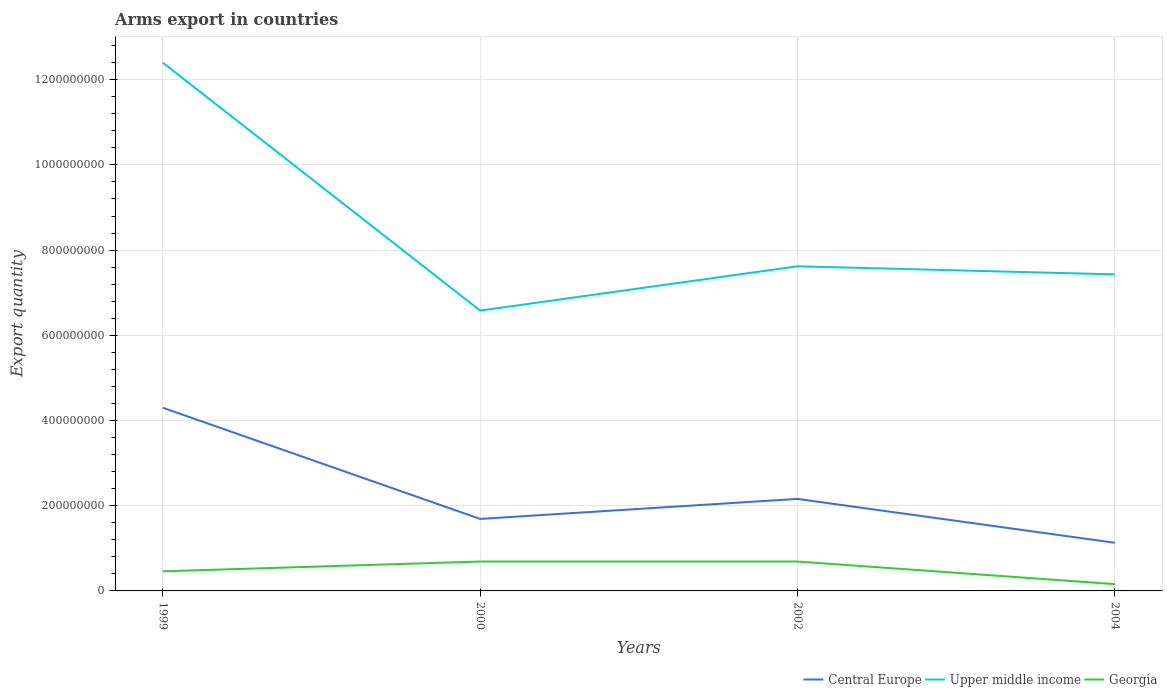How many different coloured lines are there?
Make the answer very short. 3. Does the line corresponding to Central Europe intersect with the line corresponding to Upper middle income?
Your response must be concise. No. Is the number of lines equal to the number of legend labels?
Provide a short and direct response. Yes. Across all years, what is the maximum total arms export in Central Europe?
Offer a very short reply. 1.13e+08. In which year was the total arms export in Central Europe maximum?
Provide a short and direct response. 2004. What is the total total arms export in Central Europe in the graph?
Your answer should be very brief. 3.17e+08. What is the difference between the highest and the second highest total arms export in Central Europe?
Keep it short and to the point. 3.17e+08. What is the difference between the highest and the lowest total arms export in Georgia?
Give a very brief answer. 2. How many lines are there?
Provide a short and direct response. 3. How many years are there in the graph?
Provide a succinct answer. 4. Are the values on the major ticks of Y-axis written in scientific E-notation?
Your response must be concise. No. Where does the legend appear in the graph?
Your answer should be very brief. Bottom right. How are the legend labels stacked?
Offer a very short reply. Horizontal. What is the title of the graph?
Your response must be concise. Arms export in countries. Does "Lithuania" appear as one of the legend labels in the graph?
Give a very brief answer. No. What is the label or title of the Y-axis?
Your answer should be very brief. Export quantity. What is the Export quantity in Central Europe in 1999?
Keep it short and to the point. 4.30e+08. What is the Export quantity in Upper middle income in 1999?
Provide a short and direct response. 1.24e+09. What is the Export quantity of Georgia in 1999?
Keep it short and to the point. 4.60e+07. What is the Export quantity of Central Europe in 2000?
Keep it short and to the point. 1.69e+08. What is the Export quantity of Upper middle income in 2000?
Your answer should be very brief. 6.58e+08. What is the Export quantity in Georgia in 2000?
Your answer should be compact. 6.90e+07. What is the Export quantity of Central Europe in 2002?
Your answer should be very brief. 2.16e+08. What is the Export quantity of Upper middle income in 2002?
Ensure brevity in your answer.  7.62e+08. What is the Export quantity in Georgia in 2002?
Your answer should be very brief. 6.90e+07. What is the Export quantity in Central Europe in 2004?
Provide a succinct answer. 1.13e+08. What is the Export quantity of Upper middle income in 2004?
Ensure brevity in your answer.  7.43e+08. What is the Export quantity in Georgia in 2004?
Your response must be concise. 1.60e+07. Across all years, what is the maximum Export quantity of Central Europe?
Make the answer very short. 4.30e+08. Across all years, what is the maximum Export quantity of Upper middle income?
Make the answer very short. 1.24e+09. Across all years, what is the maximum Export quantity in Georgia?
Keep it short and to the point. 6.90e+07. Across all years, what is the minimum Export quantity in Central Europe?
Ensure brevity in your answer.  1.13e+08. Across all years, what is the minimum Export quantity of Upper middle income?
Offer a terse response. 6.58e+08. Across all years, what is the minimum Export quantity of Georgia?
Provide a short and direct response. 1.60e+07. What is the total Export quantity in Central Europe in the graph?
Your response must be concise. 9.28e+08. What is the total Export quantity of Upper middle income in the graph?
Your answer should be very brief. 3.40e+09. What is the total Export quantity in Georgia in the graph?
Give a very brief answer. 2.00e+08. What is the difference between the Export quantity in Central Europe in 1999 and that in 2000?
Your response must be concise. 2.61e+08. What is the difference between the Export quantity in Upper middle income in 1999 and that in 2000?
Your answer should be very brief. 5.82e+08. What is the difference between the Export quantity of Georgia in 1999 and that in 2000?
Provide a succinct answer. -2.30e+07. What is the difference between the Export quantity in Central Europe in 1999 and that in 2002?
Your answer should be very brief. 2.14e+08. What is the difference between the Export quantity of Upper middle income in 1999 and that in 2002?
Provide a succinct answer. 4.78e+08. What is the difference between the Export quantity of Georgia in 1999 and that in 2002?
Keep it short and to the point. -2.30e+07. What is the difference between the Export quantity of Central Europe in 1999 and that in 2004?
Your response must be concise. 3.17e+08. What is the difference between the Export quantity of Upper middle income in 1999 and that in 2004?
Provide a succinct answer. 4.97e+08. What is the difference between the Export quantity in Georgia in 1999 and that in 2004?
Provide a succinct answer. 3.00e+07. What is the difference between the Export quantity of Central Europe in 2000 and that in 2002?
Your response must be concise. -4.70e+07. What is the difference between the Export quantity in Upper middle income in 2000 and that in 2002?
Your answer should be compact. -1.04e+08. What is the difference between the Export quantity of Central Europe in 2000 and that in 2004?
Your answer should be compact. 5.60e+07. What is the difference between the Export quantity of Upper middle income in 2000 and that in 2004?
Provide a short and direct response. -8.50e+07. What is the difference between the Export quantity in Georgia in 2000 and that in 2004?
Your answer should be compact. 5.30e+07. What is the difference between the Export quantity of Central Europe in 2002 and that in 2004?
Provide a succinct answer. 1.03e+08. What is the difference between the Export quantity of Upper middle income in 2002 and that in 2004?
Offer a terse response. 1.90e+07. What is the difference between the Export quantity in Georgia in 2002 and that in 2004?
Provide a short and direct response. 5.30e+07. What is the difference between the Export quantity in Central Europe in 1999 and the Export quantity in Upper middle income in 2000?
Provide a short and direct response. -2.28e+08. What is the difference between the Export quantity of Central Europe in 1999 and the Export quantity of Georgia in 2000?
Give a very brief answer. 3.61e+08. What is the difference between the Export quantity in Upper middle income in 1999 and the Export quantity in Georgia in 2000?
Your answer should be very brief. 1.17e+09. What is the difference between the Export quantity in Central Europe in 1999 and the Export quantity in Upper middle income in 2002?
Keep it short and to the point. -3.32e+08. What is the difference between the Export quantity in Central Europe in 1999 and the Export quantity in Georgia in 2002?
Keep it short and to the point. 3.61e+08. What is the difference between the Export quantity in Upper middle income in 1999 and the Export quantity in Georgia in 2002?
Make the answer very short. 1.17e+09. What is the difference between the Export quantity in Central Europe in 1999 and the Export quantity in Upper middle income in 2004?
Offer a very short reply. -3.13e+08. What is the difference between the Export quantity of Central Europe in 1999 and the Export quantity of Georgia in 2004?
Keep it short and to the point. 4.14e+08. What is the difference between the Export quantity in Upper middle income in 1999 and the Export quantity in Georgia in 2004?
Make the answer very short. 1.22e+09. What is the difference between the Export quantity in Central Europe in 2000 and the Export quantity in Upper middle income in 2002?
Ensure brevity in your answer.  -5.93e+08. What is the difference between the Export quantity in Central Europe in 2000 and the Export quantity in Georgia in 2002?
Your answer should be compact. 1.00e+08. What is the difference between the Export quantity of Upper middle income in 2000 and the Export quantity of Georgia in 2002?
Provide a succinct answer. 5.89e+08. What is the difference between the Export quantity in Central Europe in 2000 and the Export quantity in Upper middle income in 2004?
Your answer should be compact. -5.74e+08. What is the difference between the Export quantity in Central Europe in 2000 and the Export quantity in Georgia in 2004?
Make the answer very short. 1.53e+08. What is the difference between the Export quantity in Upper middle income in 2000 and the Export quantity in Georgia in 2004?
Make the answer very short. 6.42e+08. What is the difference between the Export quantity in Central Europe in 2002 and the Export quantity in Upper middle income in 2004?
Your answer should be very brief. -5.27e+08. What is the difference between the Export quantity of Upper middle income in 2002 and the Export quantity of Georgia in 2004?
Make the answer very short. 7.46e+08. What is the average Export quantity in Central Europe per year?
Offer a very short reply. 2.32e+08. What is the average Export quantity in Upper middle income per year?
Give a very brief answer. 8.51e+08. What is the average Export quantity in Georgia per year?
Provide a succinct answer. 5.00e+07. In the year 1999, what is the difference between the Export quantity of Central Europe and Export quantity of Upper middle income?
Your answer should be very brief. -8.10e+08. In the year 1999, what is the difference between the Export quantity in Central Europe and Export quantity in Georgia?
Your response must be concise. 3.84e+08. In the year 1999, what is the difference between the Export quantity in Upper middle income and Export quantity in Georgia?
Your response must be concise. 1.19e+09. In the year 2000, what is the difference between the Export quantity in Central Europe and Export quantity in Upper middle income?
Offer a terse response. -4.89e+08. In the year 2000, what is the difference between the Export quantity in Central Europe and Export quantity in Georgia?
Provide a short and direct response. 1.00e+08. In the year 2000, what is the difference between the Export quantity in Upper middle income and Export quantity in Georgia?
Your response must be concise. 5.89e+08. In the year 2002, what is the difference between the Export quantity of Central Europe and Export quantity of Upper middle income?
Give a very brief answer. -5.46e+08. In the year 2002, what is the difference between the Export quantity of Central Europe and Export quantity of Georgia?
Offer a terse response. 1.47e+08. In the year 2002, what is the difference between the Export quantity in Upper middle income and Export quantity in Georgia?
Provide a short and direct response. 6.93e+08. In the year 2004, what is the difference between the Export quantity of Central Europe and Export quantity of Upper middle income?
Your answer should be compact. -6.30e+08. In the year 2004, what is the difference between the Export quantity of Central Europe and Export quantity of Georgia?
Offer a terse response. 9.70e+07. In the year 2004, what is the difference between the Export quantity in Upper middle income and Export quantity in Georgia?
Provide a succinct answer. 7.27e+08. What is the ratio of the Export quantity of Central Europe in 1999 to that in 2000?
Your answer should be very brief. 2.54. What is the ratio of the Export quantity of Upper middle income in 1999 to that in 2000?
Give a very brief answer. 1.88. What is the ratio of the Export quantity in Central Europe in 1999 to that in 2002?
Your answer should be very brief. 1.99. What is the ratio of the Export quantity of Upper middle income in 1999 to that in 2002?
Make the answer very short. 1.63. What is the ratio of the Export quantity in Central Europe in 1999 to that in 2004?
Your answer should be compact. 3.81. What is the ratio of the Export quantity of Upper middle income in 1999 to that in 2004?
Offer a very short reply. 1.67. What is the ratio of the Export quantity of Georgia in 1999 to that in 2004?
Give a very brief answer. 2.88. What is the ratio of the Export quantity in Central Europe in 2000 to that in 2002?
Keep it short and to the point. 0.78. What is the ratio of the Export quantity in Upper middle income in 2000 to that in 2002?
Your response must be concise. 0.86. What is the ratio of the Export quantity in Central Europe in 2000 to that in 2004?
Make the answer very short. 1.5. What is the ratio of the Export quantity in Upper middle income in 2000 to that in 2004?
Provide a short and direct response. 0.89. What is the ratio of the Export quantity in Georgia in 2000 to that in 2004?
Provide a short and direct response. 4.31. What is the ratio of the Export quantity of Central Europe in 2002 to that in 2004?
Provide a succinct answer. 1.91. What is the ratio of the Export quantity in Upper middle income in 2002 to that in 2004?
Ensure brevity in your answer.  1.03. What is the ratio of the Export quantity of Georgia in 2002 to that in 2004?
Provide a short and direct response. 4.31. What is the difference between the highest and the second highest Export quantity in Central Europe?
Offer a terse response. 2.14e+08. What is the difference between the highest and the second highest Export quantity in Upper middle income?
Ensure brevity in your answer.  4.78e+08. What is the difference between the highest and the lowest Export quantity in Central Europe?
Give a very brief answer. 3.17e+08. What is the difference between the highest and the lowest Export quantity in Upper middle income?
Your response must be concise. 5.82e+08. What is the difference between the highest and the lowest Export quantity in Georgia?
Provide a short and direct response. 5.30e+07. 